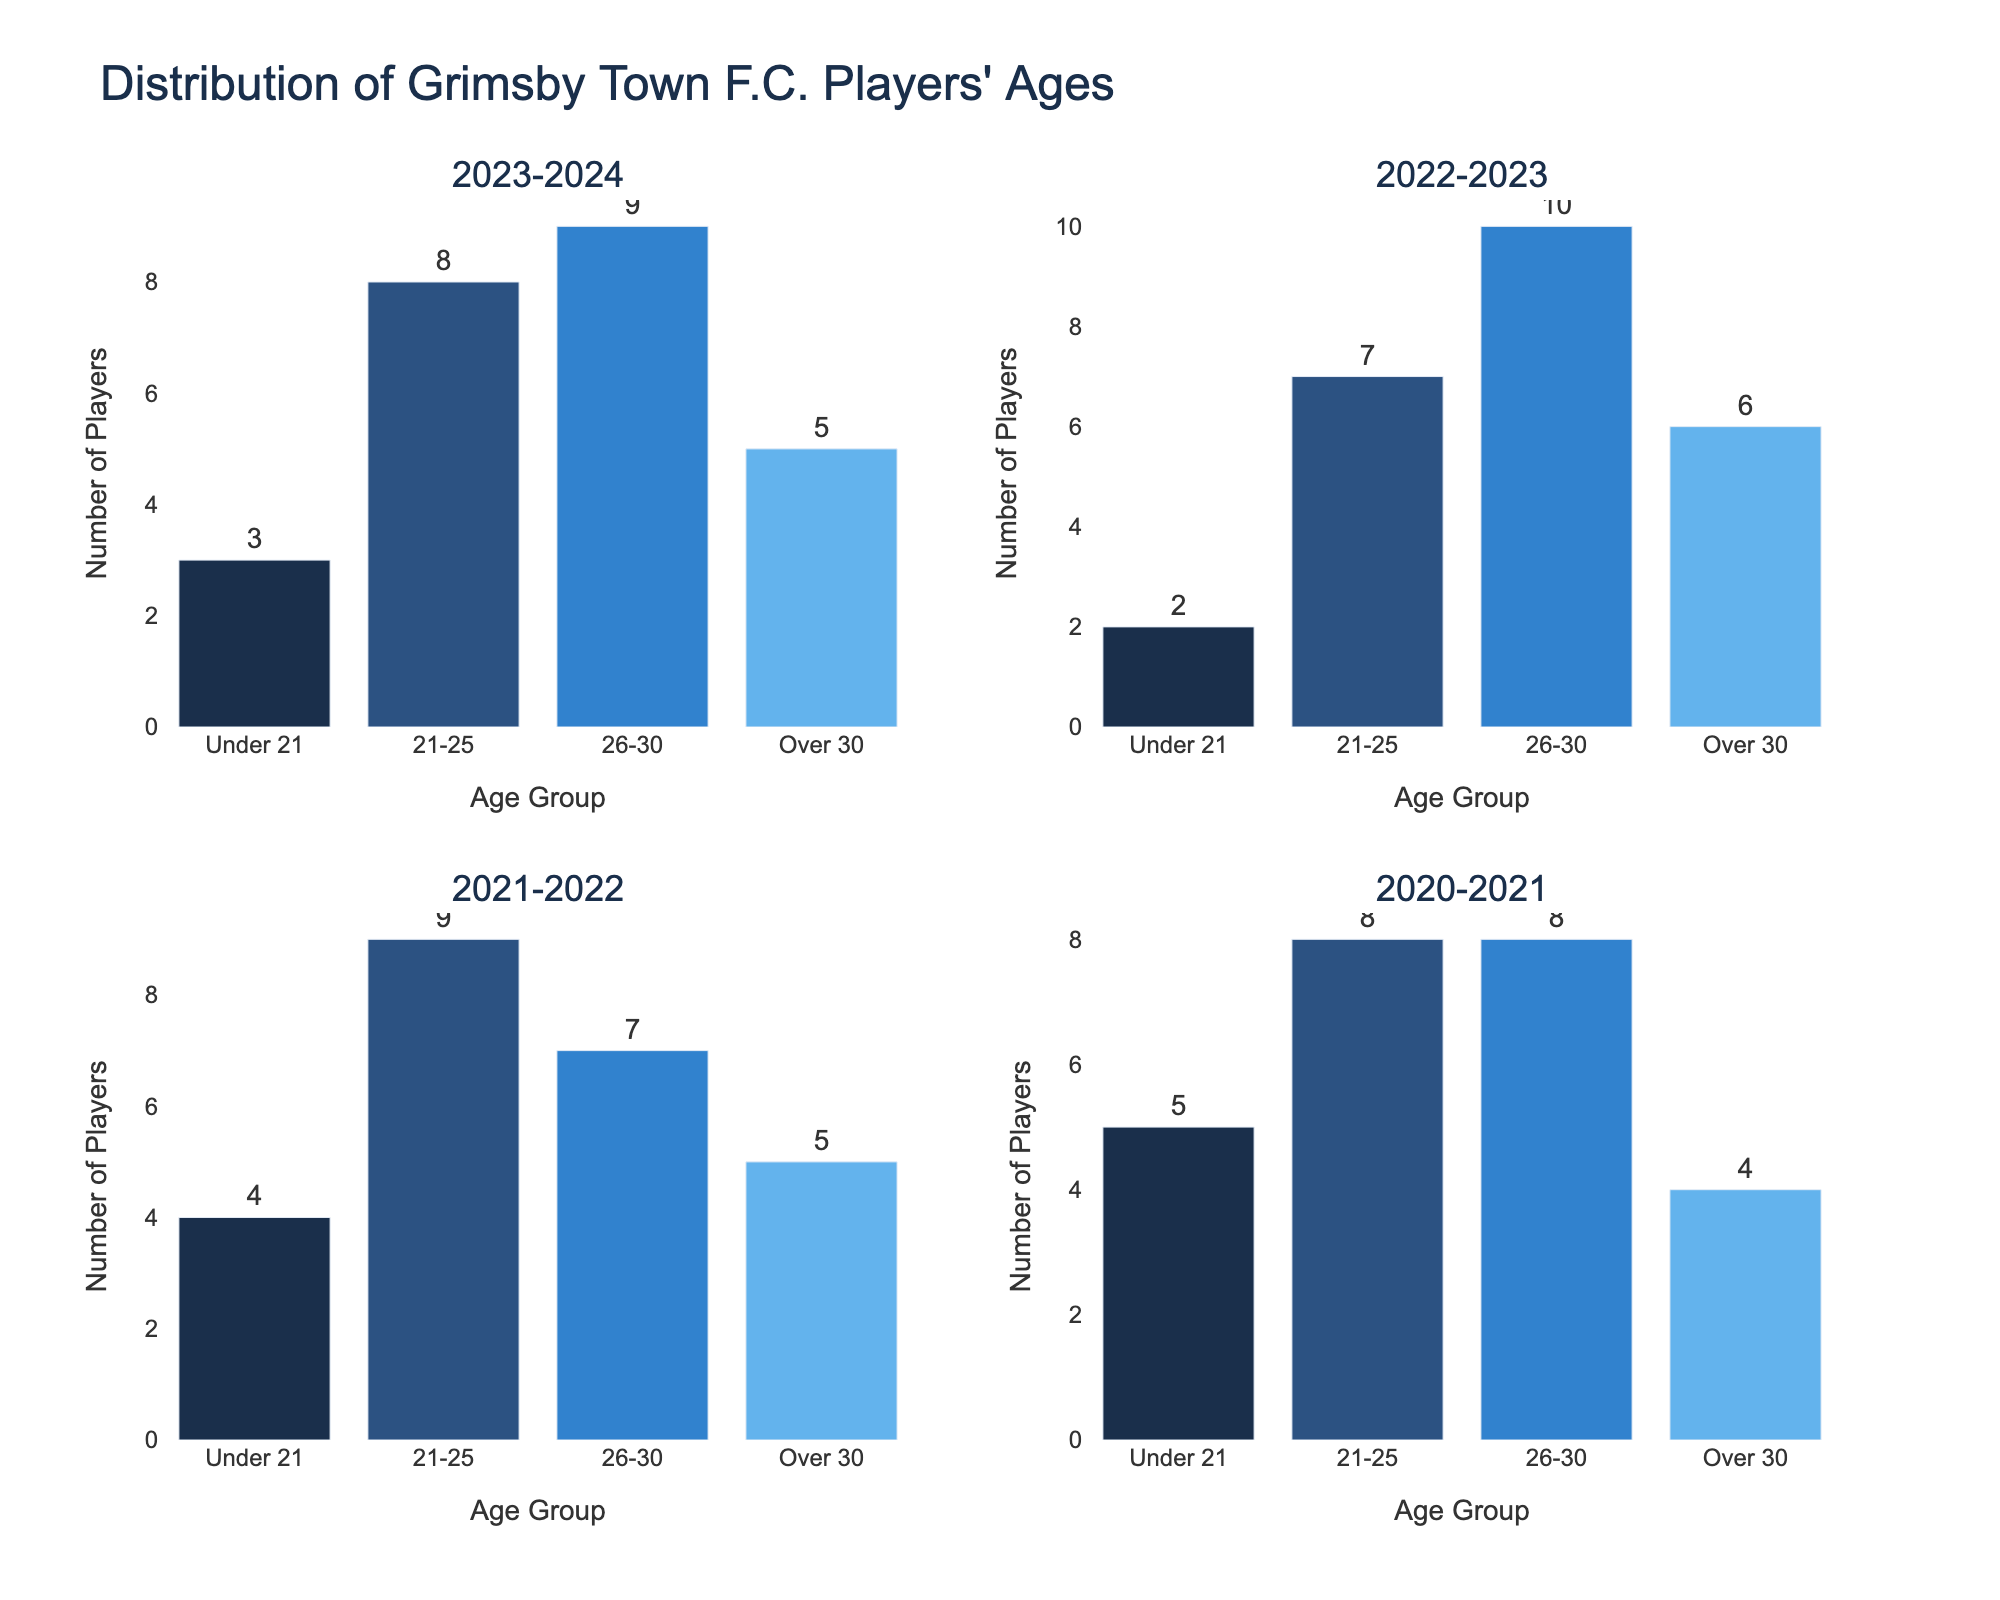What is the title of the figure? The title is displayed at the top of the figure.
Answer: Distribution of Grimsby Town F.C. Players' Ages What does the x-axis represent? The x-axis labels are shown below each bar chart, indicating the different age groups.
Answer: Age Group How many players are there in the "Under 21" age group for the 2023-2024 season? Look at the first subplot for the 2023-2024 season and find the height of the "Under 21" bar and its associated text label.
Answer: 3 Which season had the highest number of players aged 26-30? Compare the heights and labels of the 26-30 bars across all subplots.
Answer: 2022-2023 How has the number of players aged over 30 changed from the 2022-2023 season to the 2023-2024 season? Check the "Over 30" bars in the 2022-2023 and 2023-2024 subplots and calculate the difference.
Answer: Decreased by 1 What is the sum of players in the "21-25" age group for all seasons combined? Add the number of players in the "21-25" age group across all four subplots.
Answer: 32 In which season did the "Under 21" age group have the most significant decrease compared to the previous season? Calculate the difference in the number of "Under 21" players across consecutive seasons and identify the largest drop.
Answer: 2021-2022 How do the number of players aged 21-25 in the 2023-2024 season compare to the number of players in the same age group in the 2020-2021 season? Compare the heights and labels of the 21-25 bars in the subplots for the 2023-2024 and 2020-2021 seasons.
Answer: The same Which age group has consistently had 5 or more players in every season? Identify the age group(s) that have bars with a height of 5 or more players in every subplot.
Answer: Over 30 What trend can be observed in the number of players under 21 from the 2020-2021 season to the 2023-2024 season? Look at the heights and labels of the "Under 21" bars across all seasons to determine the trend.
Answer: Decreasing 